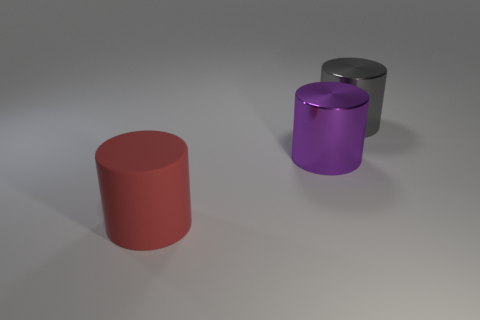Does the lighting in this scene indicate a specific time of day or setting? The lighting in the image appears neutral and artificial, suggesting that the scene is not indicative of a particular time of day. It could be an indoor setting with controlled lighting conditions, ideal for showcasing the objects without any shadows or highlights that might occur in natural sunlight.  What might be the purpose of these objects or their arrangement? The objects could serve an educational purpose - demonstrating geometric shapes, color contrast, or the effects of light on different surfaces. The arrangement itself, with even spacing and direct alignment, further suggests a display meant for observation, study, or perhaps a form of minimalist art. 